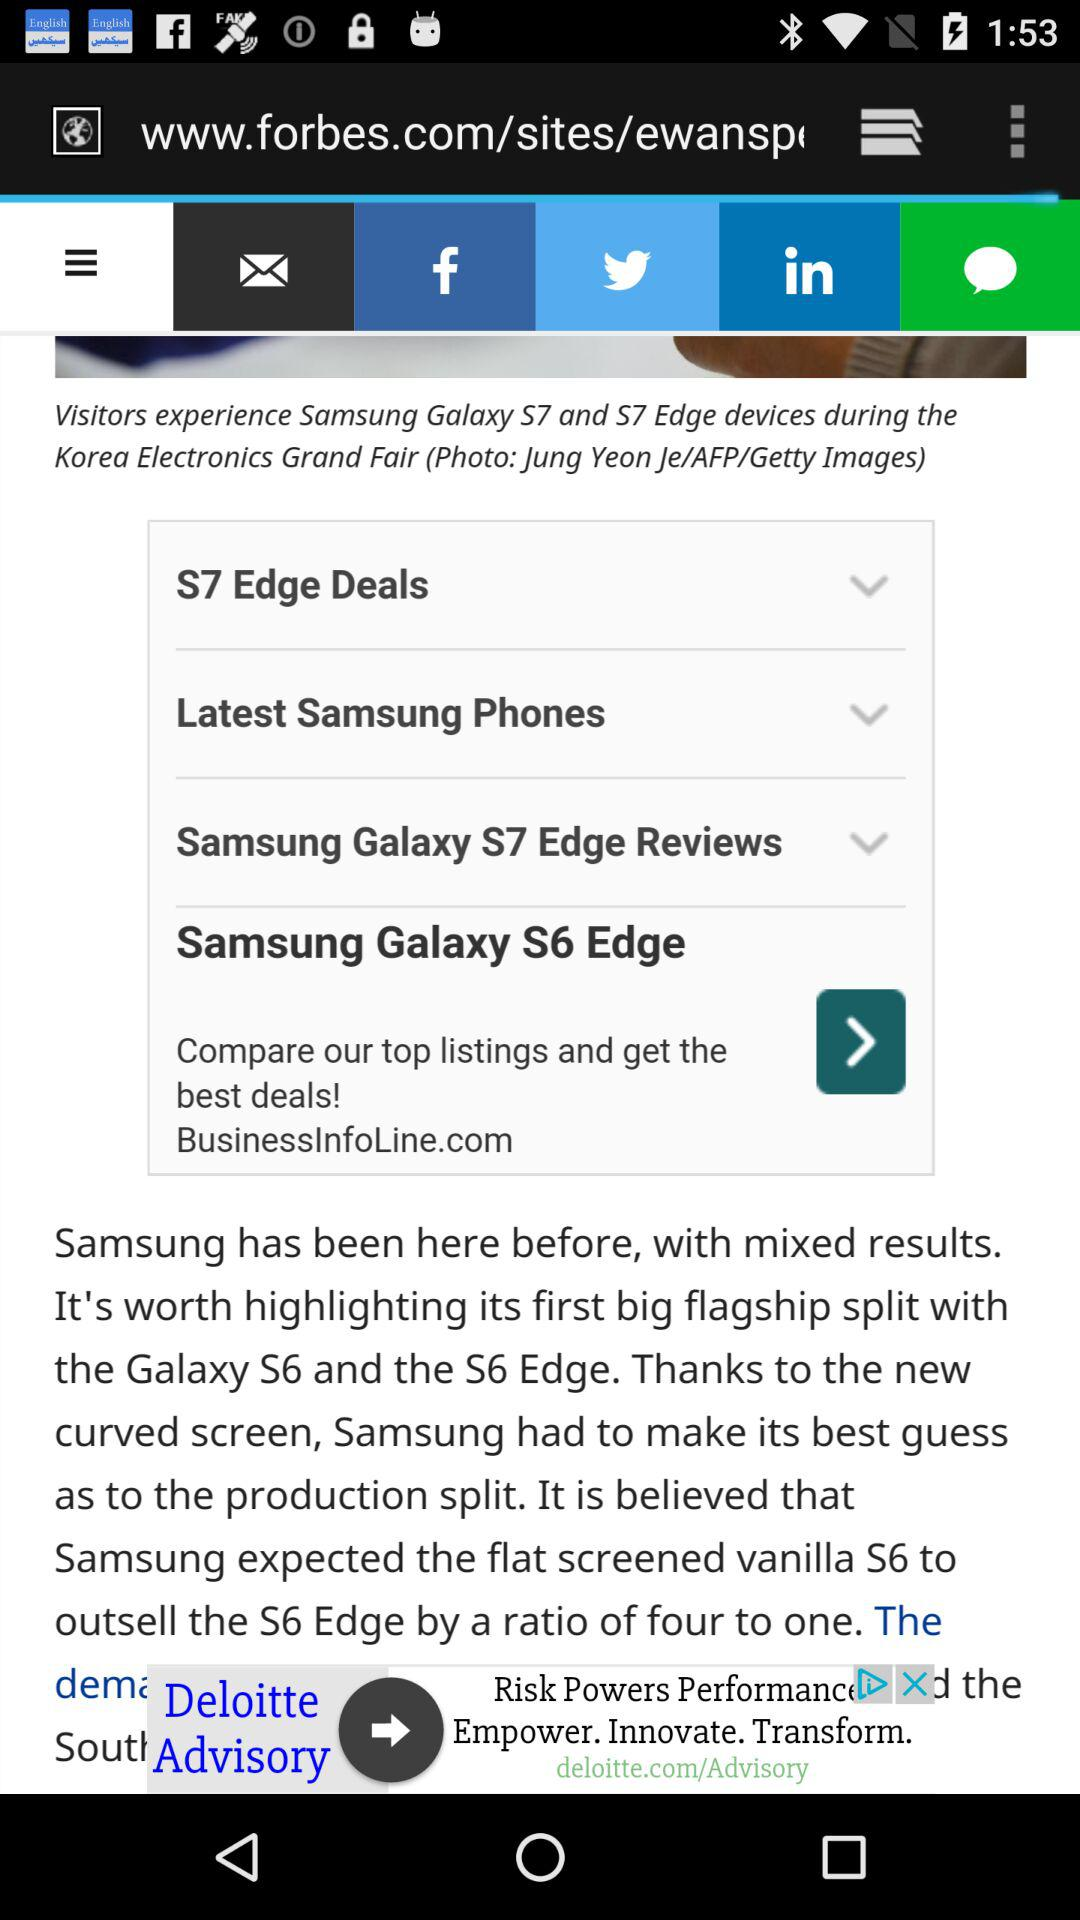What is the Samsung "flat-screened Vanila S6 to outsell the S6 Edge" ratio? It is a ratio of "four to one". 